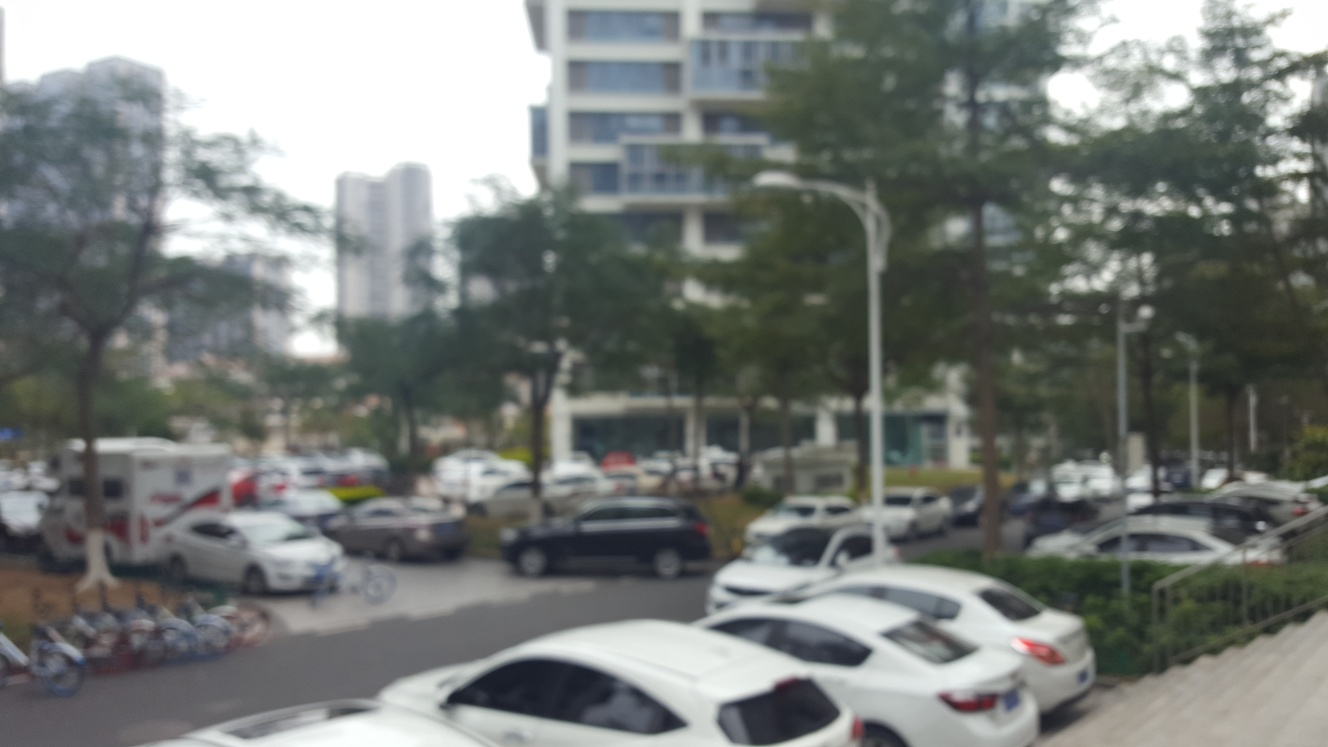How would you describe the preservation of texture and details in this image? Based on the visible lack of sharpness and detail, which results in a nearly indiscernible scene, the preservation of texture and details in this image would be most accurately described as poor. This judgement is due to the evident blurring across the entire image, a quality that obscures finer details that would otherwise contribute to a visual appreciation of depth, clarity, and context. 